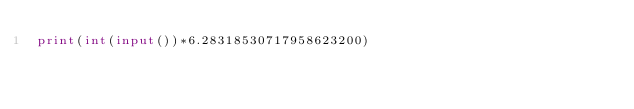Convert code to text. <code><loc_0><loc_0><loc_500><loc_500><_Python_>print(int(input())*6.28318530717958623200)</code> 